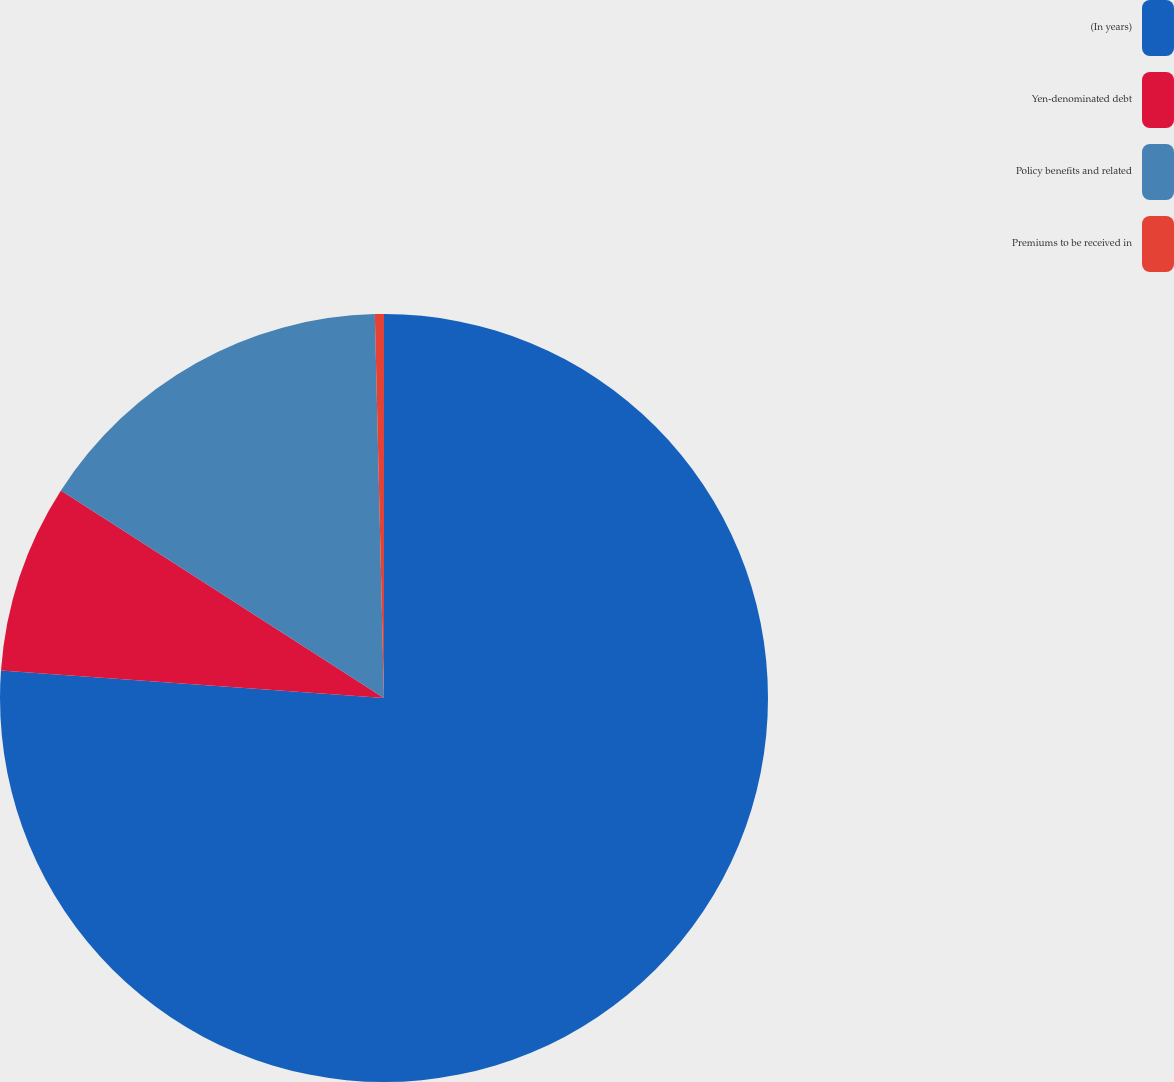Convert chart. <chart><loc_0><loc_0><loc_500><loc_500><pie_chart><fcel>(In years)<fcel>Yen-denominated debt<fcel>Policy benefits and related<fcel>Premiums to be received in<nl><fcel>76.14%<fcel>7.95%<fcel>15.53%<fcel>0.38%<nl></chart> 